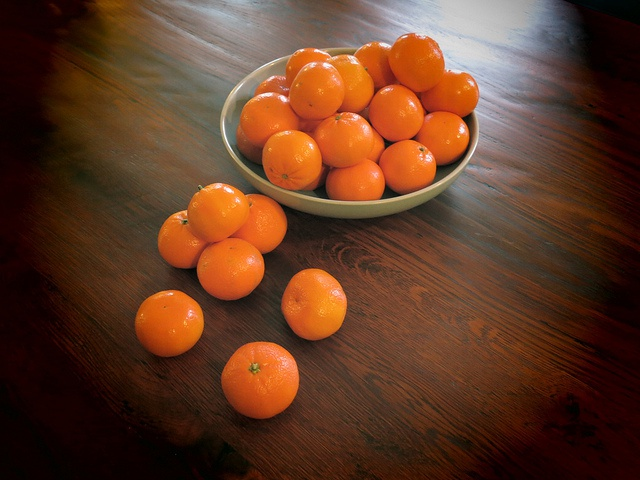Describe the objects in this image and their specific colors. I can see dining table in black, maroon, and gray tones, bowl in black, red, and brown tones, orange in black, red, brown, and salmon tones, orange in black, red, brown, and salmon tones, and orange in black, red, orange, and brown tones in this image. 